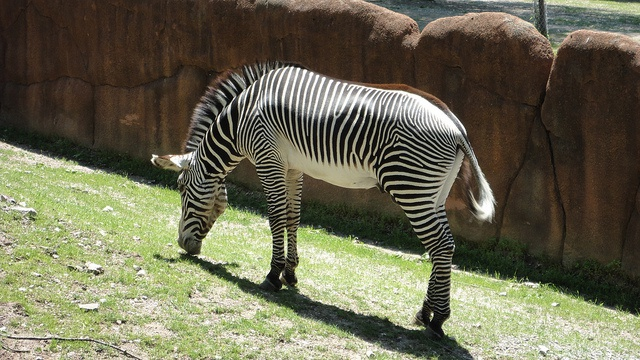Describe the objects in this image and their specific colors. I can see a zebra in black, darkgray, gray, and white tones in this image. 